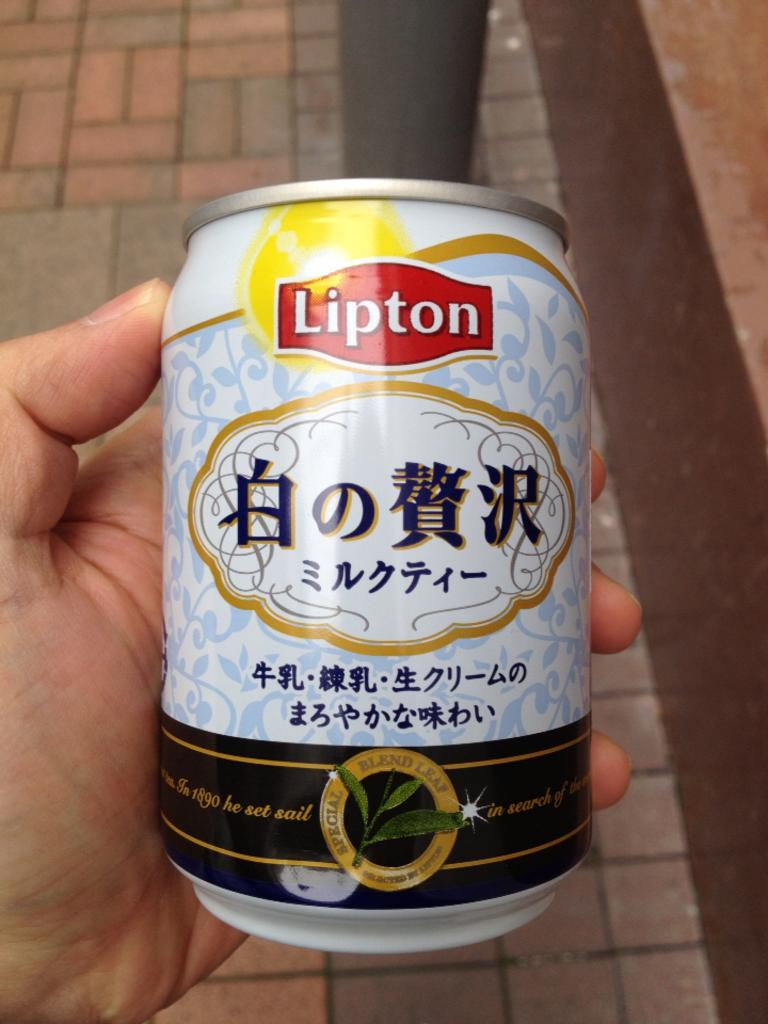<image>
Offer a succinct explanation of the picture presented. Person holding a can which says Lipton on it. 